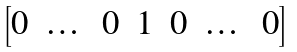Convert formula to latex. <formula><loc_0><loc_0><loc_500><loc_500>\begin{bmatrix} 0 & \dots & 0 & 1 & 0 & \dots & 0 \\ \end{bmatrix}</formula> 